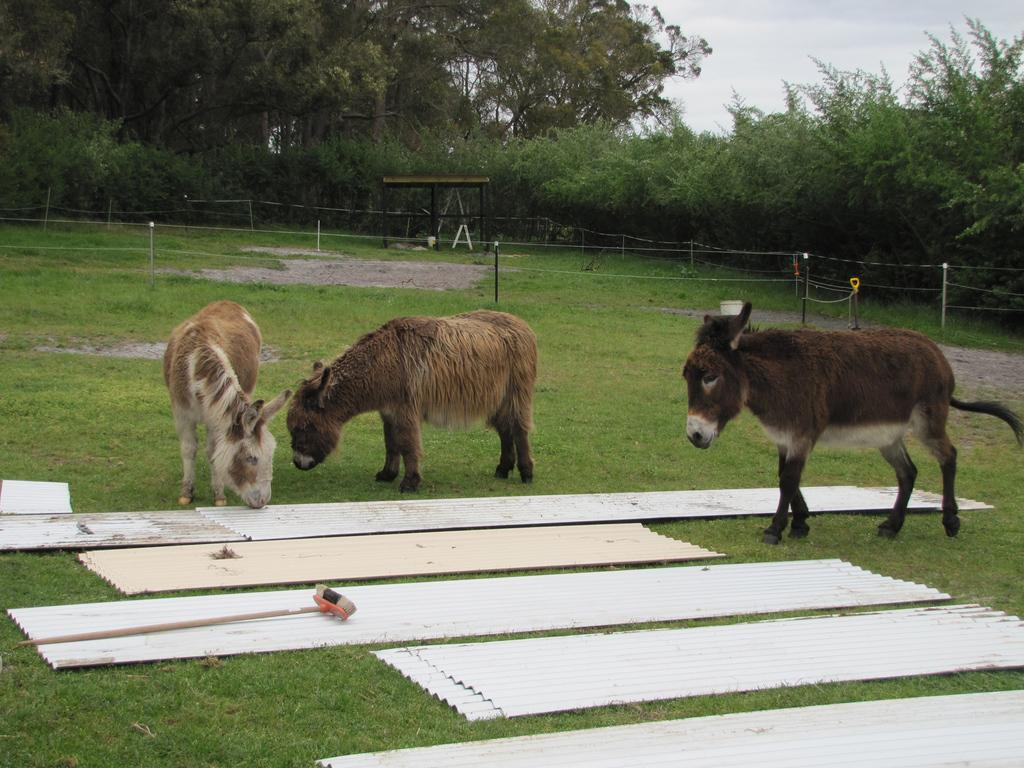What objects are located in the foreground of the image? There are steel tins and grass in the foreground of the image. What can be seen in the middle of the image? There is an animal in the middle of the image. What type of vegetation is visible at the top of the image? There are trees visible at the top of the image. Are there any islands visible in the image? There is no island present in the image. Can you spot any jellyfish in the image? There are no jellyfish present in the image. 